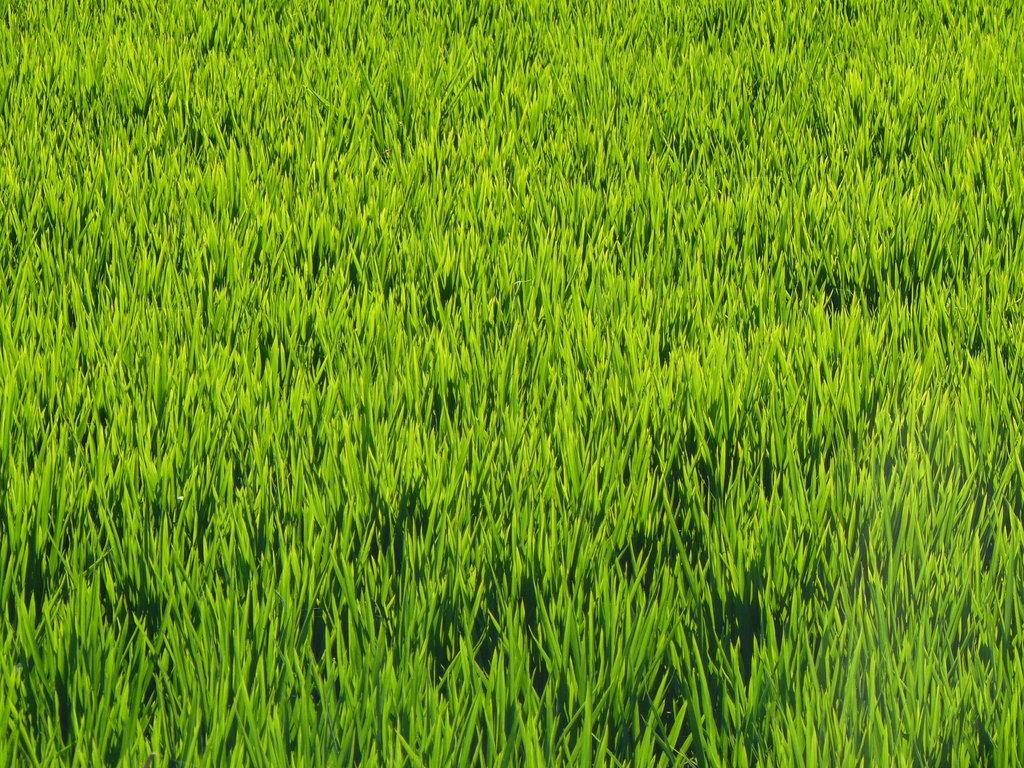What type of vegetation can be seen in the image? There is green-colored grass in the image. What type of print can be seen on the grass in the image? There is no print visible on the grass in the image; it is simply green-colored. What health benefits does the grass in the image provide? The image does not provide information about the health benefits of the grass. 